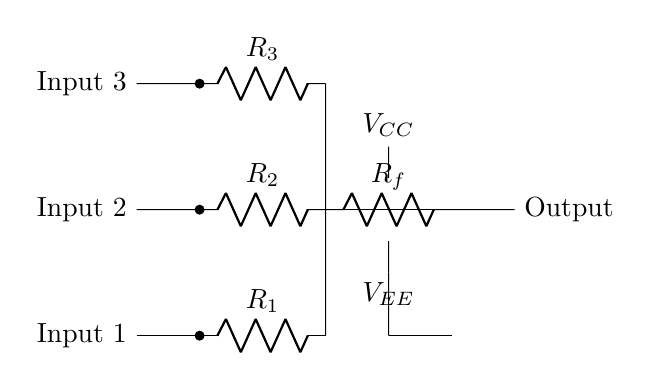What are the three input channels labeled as? The three input channels are labeled as Input 1, Input 2, and Input 3, which can be seen on the left side of the circuit diagram.
Answer: Input 1, Input 2, Input 3 What type of components are used for the input resistors? The input resistors are designated by the symbol "R," specifically R1, R2, and R3, which are typical resistors used to limit current in audio mixing circuits.
Answer: Resistors How many inputs are mixed in this circuit? There are three inputs shown in the circuit, represented by the three input channels leading into the circuit.
Answer: Three What is the purpose of the feedback resistor denoted as Rf? The feedback resistor Rf is used to set the gain of the operational amplifier and influence the mixing levels of the inputs by controlling feedback.
Answer: To set gain Which component functions as the summing amplifier in the circuit? The operational amplifier, indicated by the op-amp symbol, acts as the summing amplifier that combines the inputs into a single output signal.
Answer: Operational amplifier What voltages are connected to the operational amplifier? The operational amplifier is powered by two voltages shown as V_CC and V_EE, providing the necessary power to the op-amp for operation.
Answer: V_CC and V_EE 